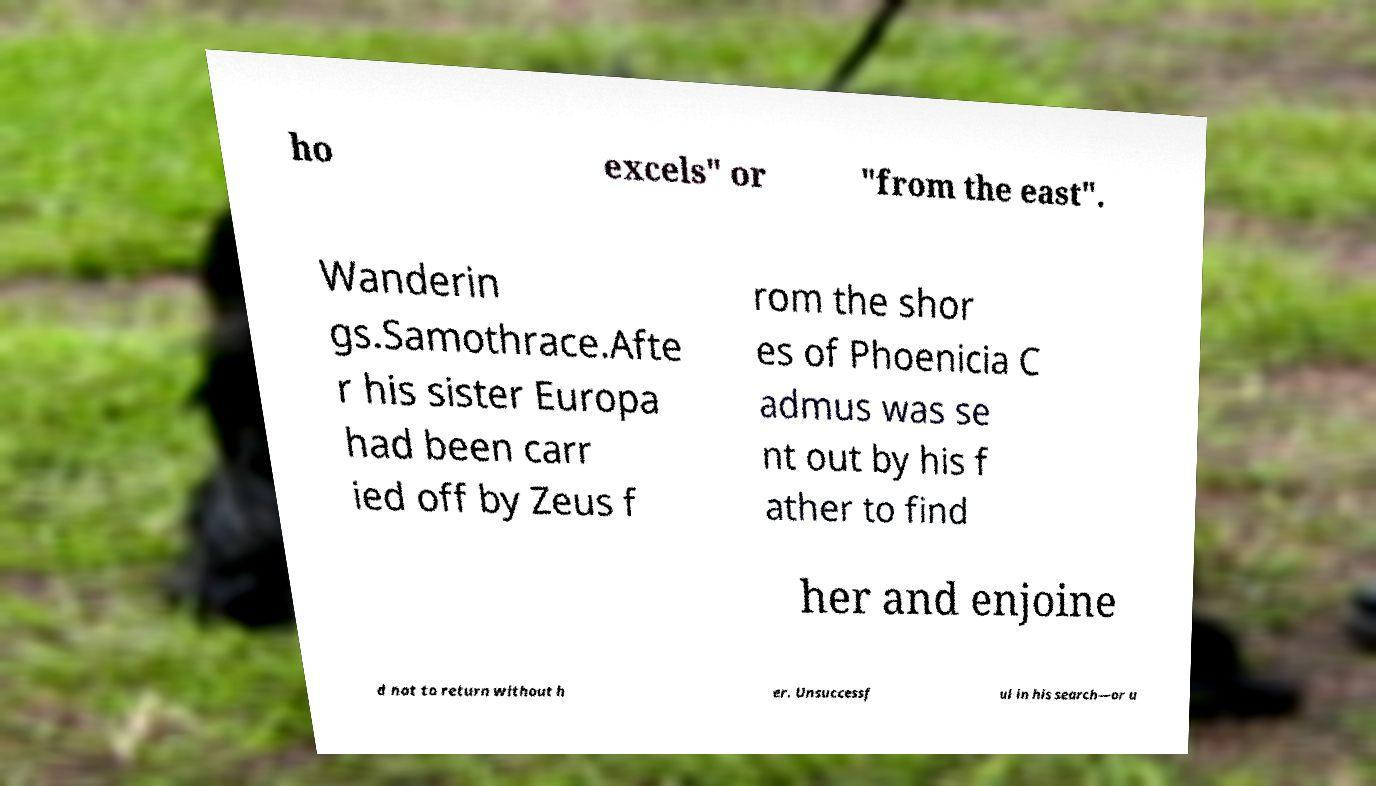Can you accurately transcribe the text from the provided image for me? ho excels" or "from the east". Wanderin gs.Samothrace.Afte r his sister Europa had been carr ied off by Zeus f rom the shor es of Phoenicia C admus was se nt out by his f ather to find her and enjoine d not to return without h er. Unsuccessf ul in his search—or u 